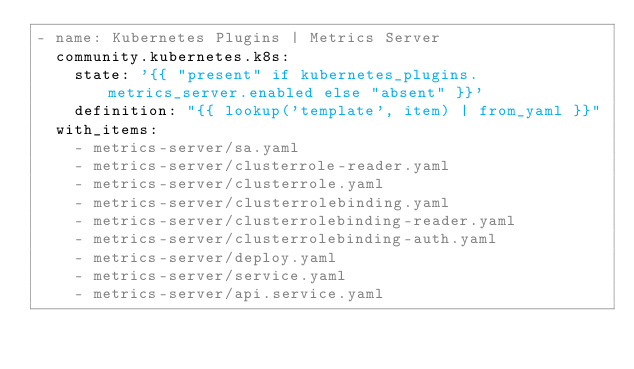<code> <loc_0><loc_0><loc_500><loc_500><_YAML_>- name: Kubernetes Plugins | Metrics Server
  community.kubernetes.k8s:
    state: '{{ "present" if kubernetes_plugins.metrics_server.enabled else "absent" }}'
    definition: "{{ lookup('template', item) | from_yaml }}"
  with_items:
    - metrics-server/sa.yaml
    - metrics-server/clusterrole-reader.yaml
    - metrics-server/clusterrole.yaml
    - metrics-server/clusterrolebinding.yaml
    - metrics-server/clusterrolebinding-reader.yaml
    - metrics-server/clusterrolebinding-auth.yaml
    - metrics-server/deploy.yaml
    - metrics-server/service.yaml
    - metrics-server/api.service.yaml
</code> 